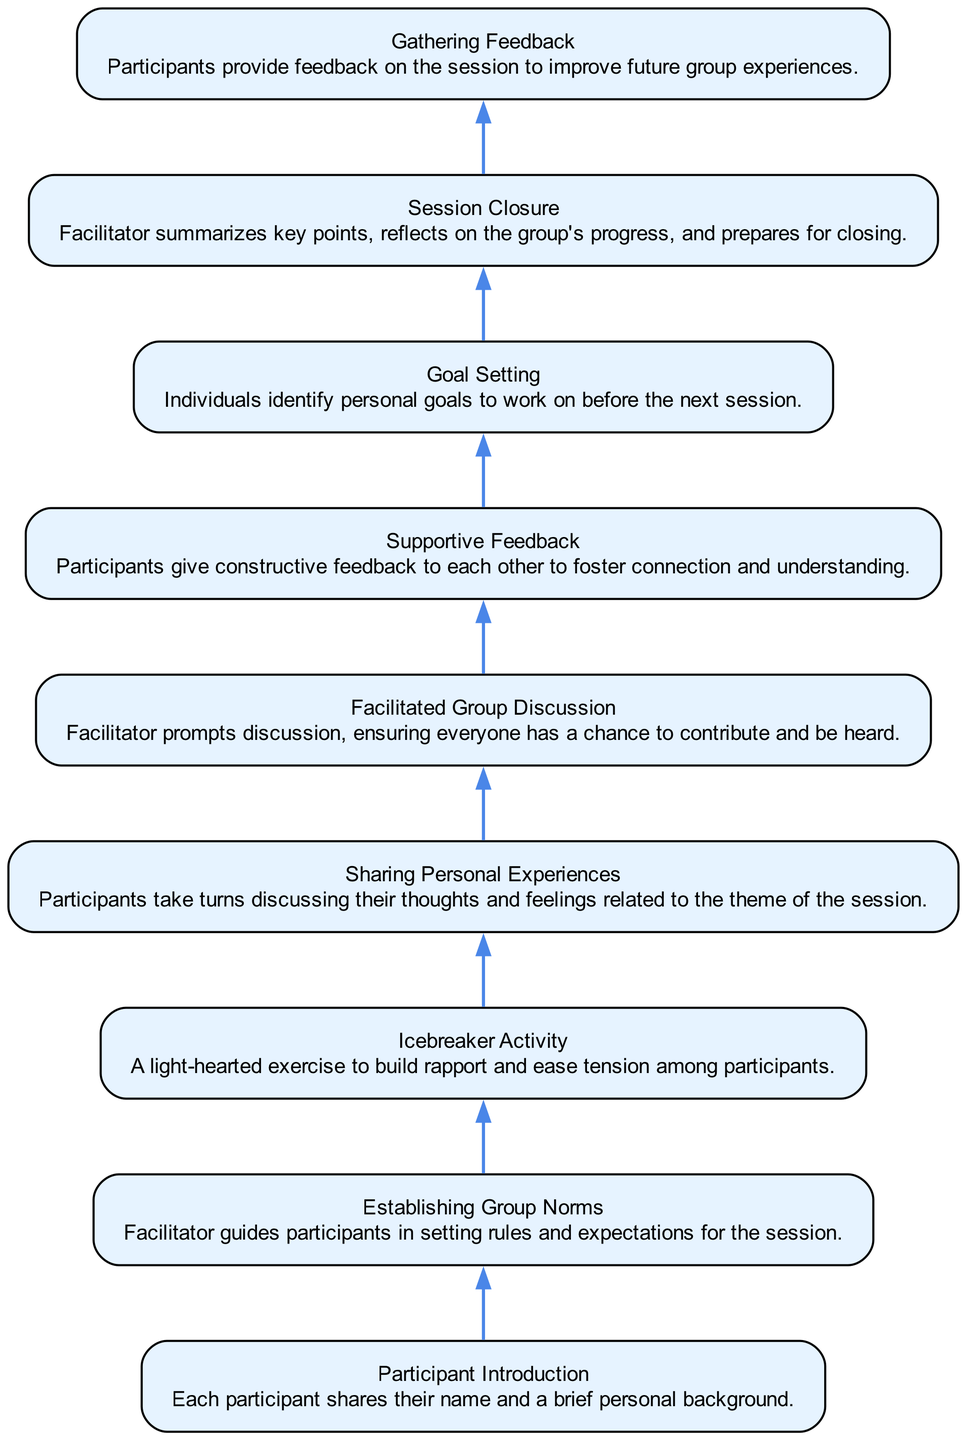What is the first activity listed in the diagram? The first activity in the diagram is "Participant Introduction," as it is the first node from the bottom up flow chart.
Answer: Participant Introduction How many activities are shown in the diagram? There are a total of 9 activities depicted in the diagram, as it lists each one sequentially.
Answer: 9 What follows after "Icebreaker Activity"? After "Icebreaker Activity," the next activity in the flow is "Sharing Personal Experiences," making it the subsequent step in the process.
Answer: Sharing Personal Experiences Which activity involves providing feedback? The activity that involves providing feedback is "Supportive Feedback," where participants give constructive feedback to each other.
Answer: Supportive Feedback What is the last activity before gathering feedback? The last activity before gathering feedback is "Session Closure," summarizing the session's key points.
Answer: Session Closure Which activities focus on participant interaction? The activities focusing on participant interaction include "Icebreaker Activity," "Sharing Personal Experiences," "Facilitated Group Discussion," and "Supportive Feedback," promoting collaboration and connection.
Answer: Icebreaker Activity, Sharing Personal Experiences, Facilitated Group Discussion, Supportive Feedback What is the purpose of "Goal Setting"? The purpose of "Goal Setting" is for individuals to identify personal goals to work on before the next session, facilitating personal growth.
Answer: For identifying personal goals Which activity explicitly mentions rules and expectations? The activity that mentions rules and expectations is "Establishing Group Norms," where the facilitator guides participants in setting these frameworks.
Answer: Establishing Group Norms How does "Facilitated Group Discussion" relate to "Supportive Feedback"? "Facilitated Group Discussion" precedes "Supportive Feedback," creating a context where participants can discuss and then give constructive feedback based on the discussion.
Answer: It precedes it and creates context for feedback 